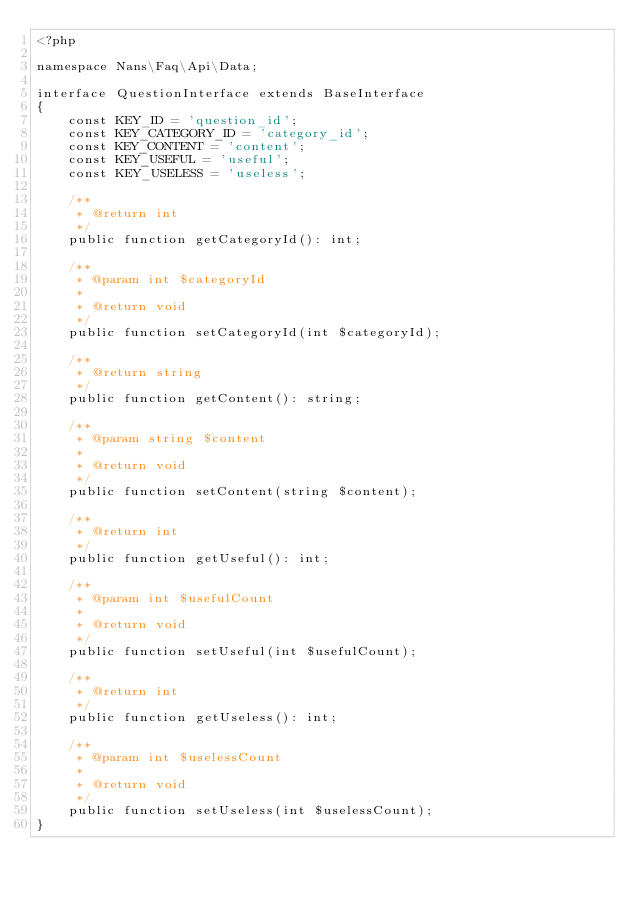<code> <loc_0><loc_0><loc_500><loc_500><_PHP_><?php

namespace Nans\Faq\Api\Data;

interface QuestionInterface extends BaseInterface
{
    const KEY_ID = 'question_id';
    const KEY_CATEGORY_ID = 'category_id';
    const KEY_CONTENT = 'content';
    const KEY_USEFUL = 'useful';
    const KEY_USELESS = 'useless';

    /**
     * @return int
     */
    public function getCategoryId(): int;

    /**
     * @param int $categoryId
     *
     * @return void
     */
    public function setCategoryId(int $categoryId);

    /**
     * @return string
     */
    public function getContent(): string;

    /**
     * @param string $content
     *
     * @return void
     */
    public function setContent(string $content);

    /**
     * @return int
     */
    public function getUseful(): int;

    /**
     * @param int $usefulCount
     *
     * @return void
     */
    public function setUseful(int $usefulCount);

    /**
     * @return int
     */
    public function getUseless(): int;

    /**
     * @param int $uselessCount
     *
     * @return void
     */
    public function setUseless(int $uselessCount);
}</code> 